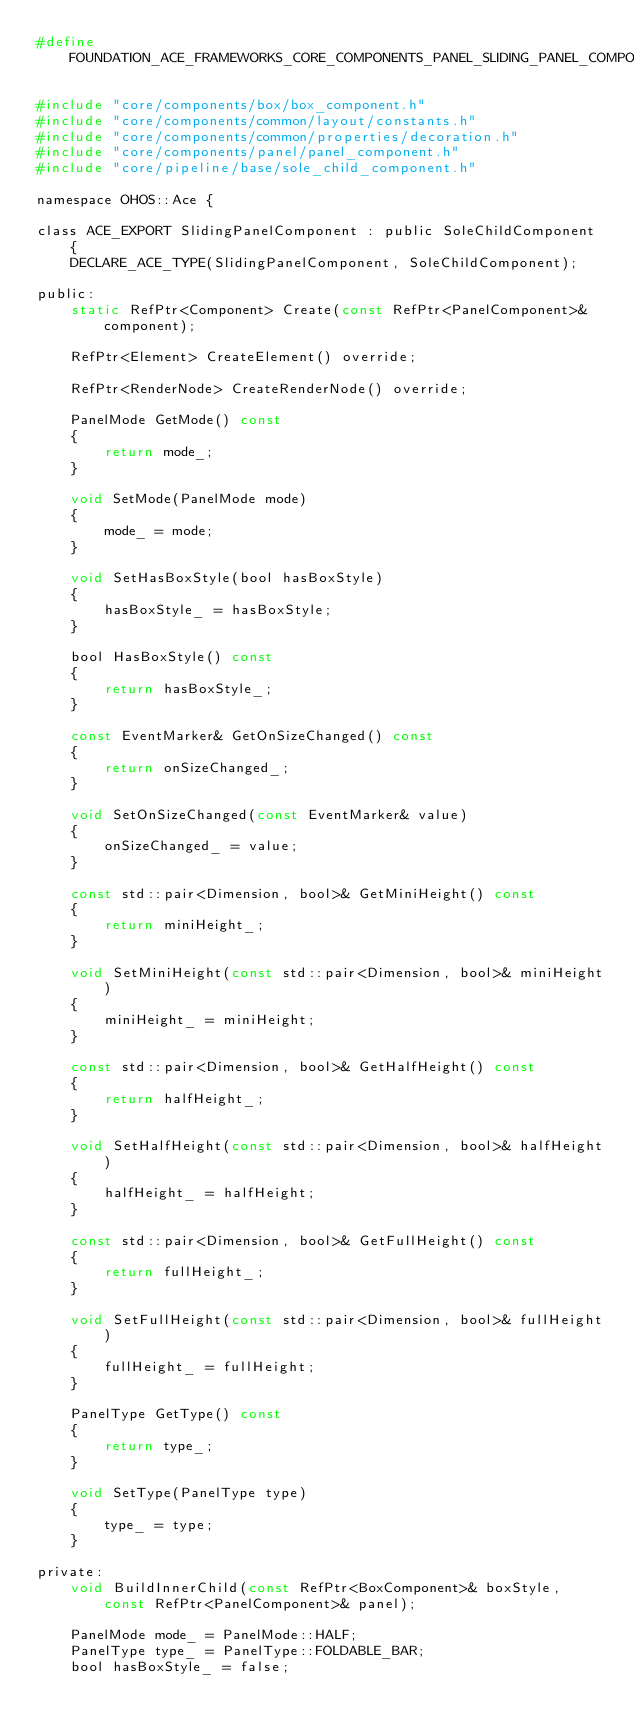<code> <loc_0><loc_0><loc_500><loc_500><_C_>#define FOUNDATION_ACE_FRAMEWORKS_CORE_COMPONENTS_PANEL_SLIDING_PANEL_COMPONENT_H

#include "core/components/box/box_component.h"
#include "core/components/common/layout/constants.h"
#include "core/components/common/properties/decoration.h"
#include "core/components/panel/panel_component.h"
#include "core/pipeline/base/sole_child_component.h"

namespace OHOS::Ace {

class ACE_EXPORT SlidingPanelComponent : public SoleChildComponent {
    DECLARE_ACE_TYPE(SlidingPanelComponent, SoleChildComponent);

public:
    static RefPtr<Component> Create(const RefPtr<PanelComponent>& component);

    RefPtr<Element> CreateElement() override;

    RefPtr<RenderNode> CreateRenderNode() override;

    PanelMode GetMode() const
    {
        return mode_;
    }

    void SetMode(PanelMode mode)
    {
        mode_ = mode;
    }

    void SetHasBoxStyle(bool hasBoxStyle)
    {
        hasBoxStyle_ = hasBoxStyle;
    }

    bool HasBoxStyle() const
    {
        return hasBoxStyle_;
    }

    const EventMarker& GetOnSizeChanged() const
    {
        return onSizeChanged_;
    }

    void SetOnSizeChanged(const EventMarker& value)
    {
        onSizeChanged_ = value;
    }

    const std::pair<Dimension, bool>& GetMiniHeight() const
    {
        return miniHeight_;
    }

    void SetMiniHeight(const std::pair<Dimension, bool>& miniHeight)
    {
        miniHeight_ = miniHeight;
    }

    const std::pair<Dimension, bool>& GetHalfHeight() const
    {
        return halfHeight_;
    }

    void SetHalfHeight(const std::pair<Dimension, bool>& halfHeight)
    {
        halfHeight_ = halfHeight;
    }

    const std::pair<Dimension, bool>& GetFullHeight() const
    {
        return fullHeight_;
    }

    void SetFullHeight(const std::pair<Dimension, bool>& fullHeight)
    {
        fullHeight_ = fullHeight;
    }

    PanelType GetType() const
    {
        return type_;
    }

    void SetType(PanelType type)
    {
        type_ = type;
    }

private:
    void BuildInnerChild(const RefPtr<BoxComponent>& boxStyle, const RefPtr<PanelComponent>& panel);

    PanelMode mode_ = PanelMode::HALF;
    PanelType type_ = PanelType::FOLDABLE_BAR;
    bool hasBoxStyle_ = false;</code> 